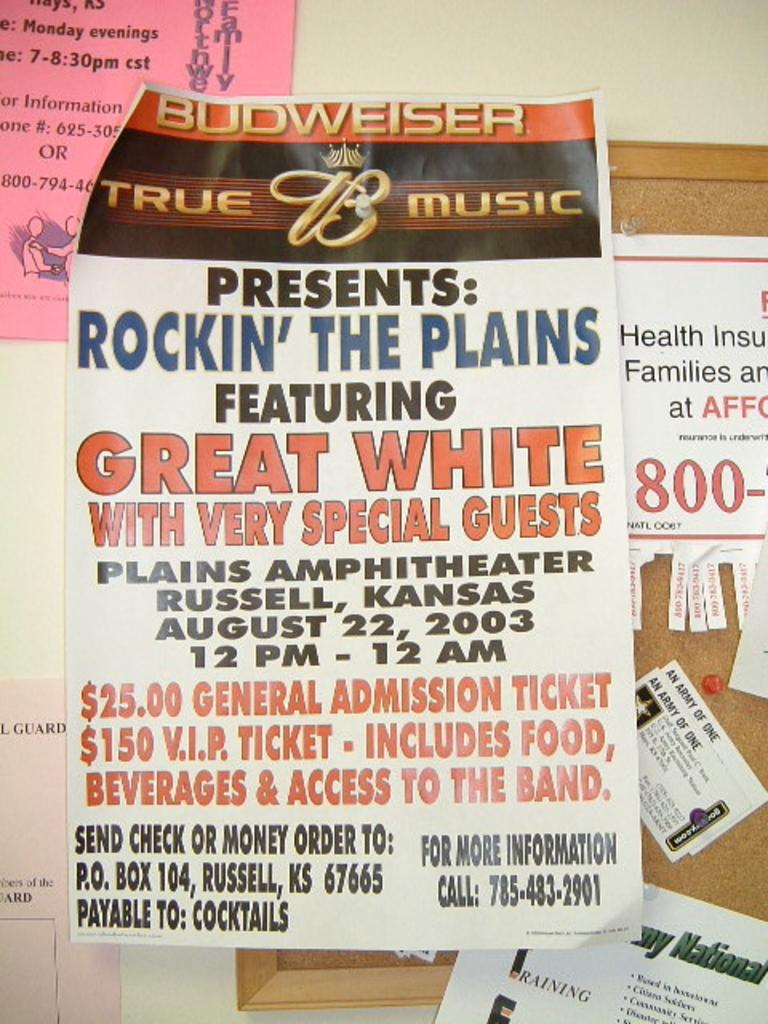Provide a one-sentence caption for the provided image. Poster showcasing a music group date time and price of tickets. 